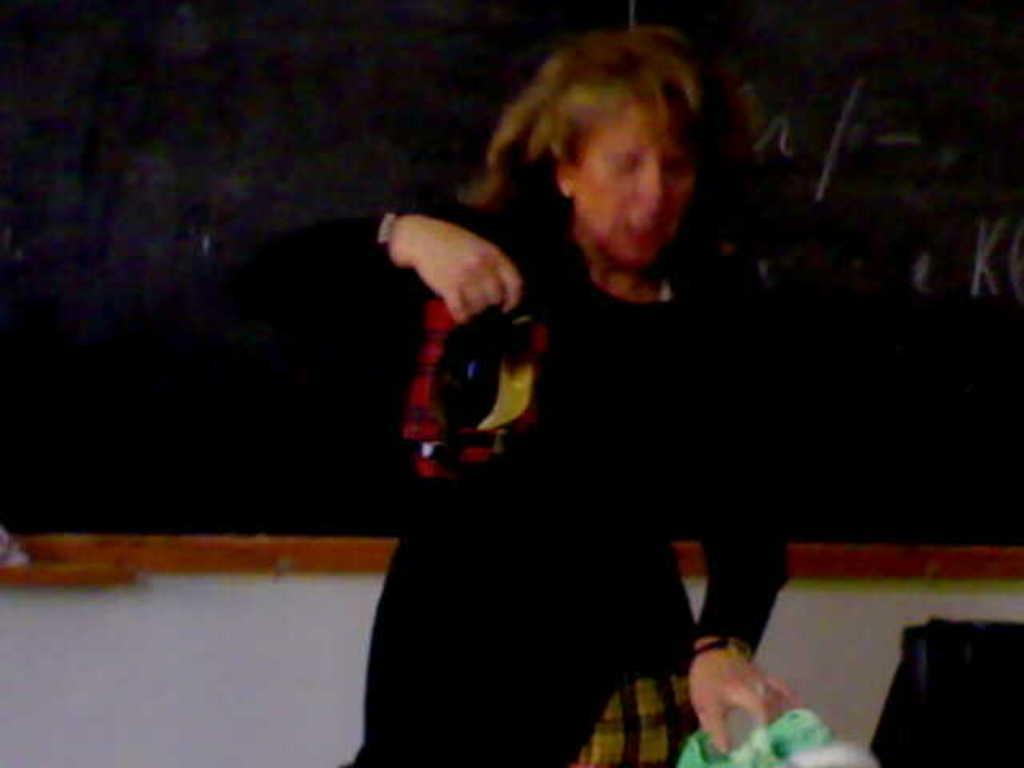Please provide a concise description of this image. In this picture we can see a woman holding an object with her hand. There is a bag. In the background we can see a wall and a black board. 